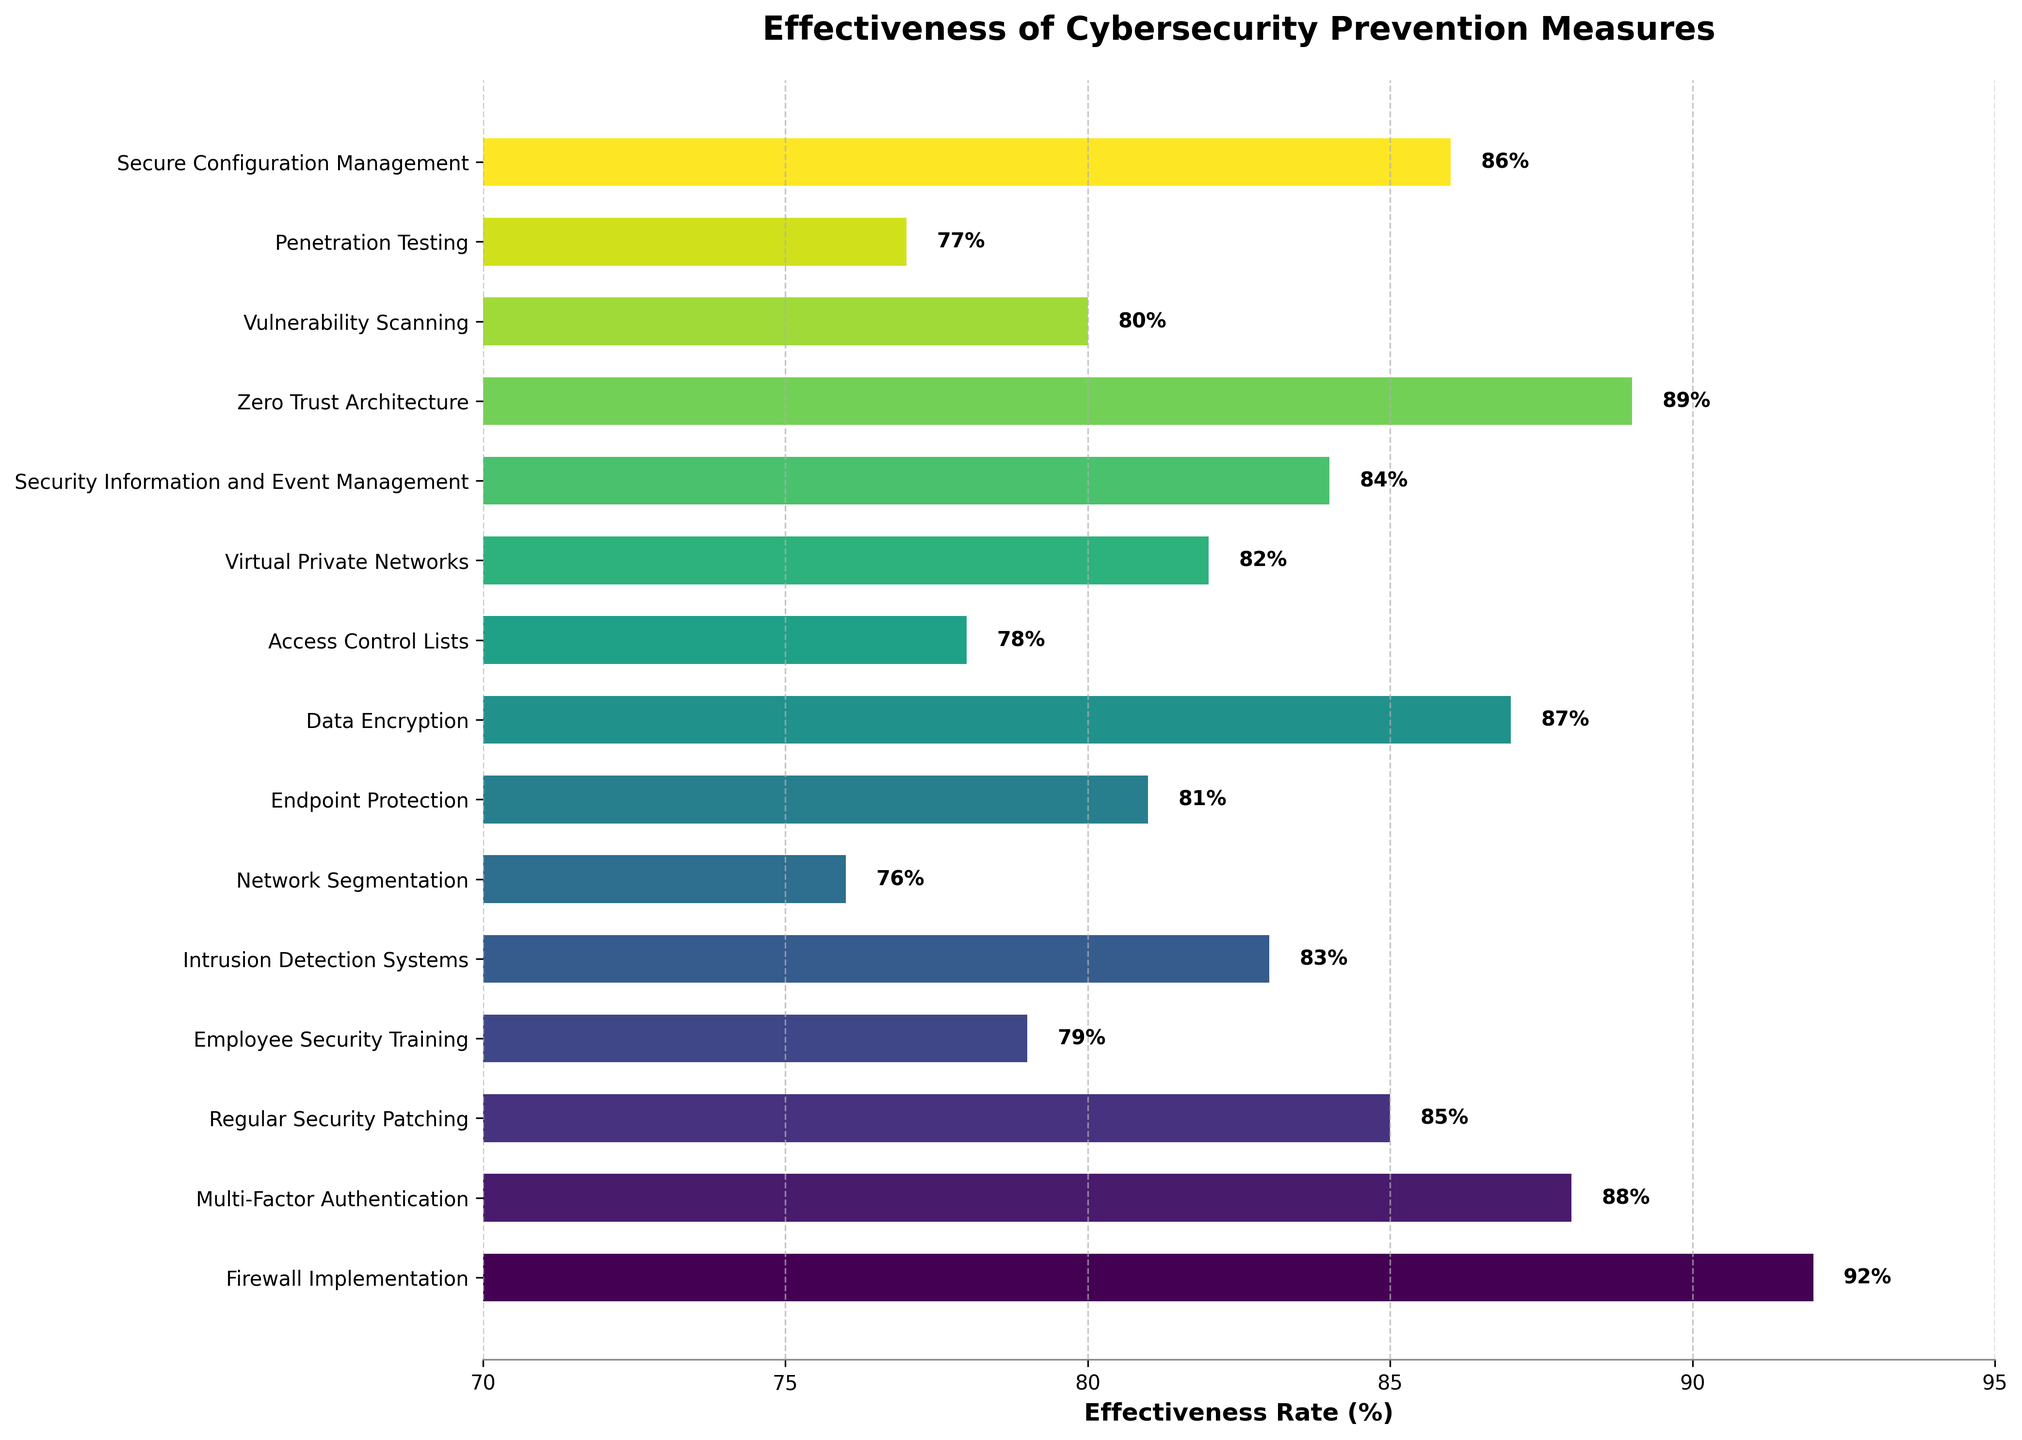Which cybersecurity measure is most effective according to the figure? The measure with the highest effectiveness rate is the most effective. In the figure, Firewall Implementation has the highest effectiveness rate at 92%.
Answer: Firewall Implementation How does the effectiveness of Multi-Factor Authentication compare to that of Data Encryption? To compare the effectiveness, we need to look at the effectiveness rates for both measures. Multi-Factor Authentication has an 88% effectiveness rate and Data Encryption has an 87% effectiveness rate.
Answer: Multi-Factor Authentication is slightly more effective Which measure has the lowest effectiveness rate? The measure with the smallest bar or lowest number in the effectiveness rate is the least effective. In the figure, Network Segmentation has the lowest effectiveness rate at 76%.
Answer: Network Segmentation By how much does the effectiveness of Zero Trust Architecture exceed Access Control Lists? To find the difference in effectiveness, we subtract the smaller rate from the higher rate. The effectiveness rate of Zero Trust Architecture is 89% and that of Access Control Lists is 78%. So, 89% - 78% = 11%.
Answer: 11% What is the average effectiveness rate of the top three most effective measures? To get the average, sum the effectiveness rates of the top three measures and divide by three. The top three measures are Firewall Implementation (92%), Zero Trust Architecture (89%), and Multi-Factor Authentication (88%). So, (92% + 89% + 88%) / 3 = 89.67%.
Answer: 89.67% Which measure among Endpoint Protection, Intrusion Detection Systems, and Penetration Testing has the highest effectiveness rate? We look at the effectiveness rates of Endpoint Protection (81%), Intrusion Detection Systems (83%), and Penetration Testing (77%). Intrusion Detection Systems has the highest rate.
Answer: Intrusion Detection Systems What are the two closest measures in terms of effectiveness rate? To find the closest measures, compare the differences between the adjacent bars. Data Encryption and Secure Configuration Management are closest with rates of 87% and 86%, respectively.
Answer: Data Encryption and Secure Configuration Management Which measure is directly above Multi-Factor Authentication in terms of effectiveness rate? Multi-Factor Authentication has an effectiveness rate of 88%. The measure directly above is Zero Trust Architecture with an effectiveness rate of 89%.
Answer: Zero Trust Architecture What is the total combined effectiveness rate of Firewall Implementation, Regular Security Patching, and Employee Security Training? To find the total combined rate, add the effectiveness rates of these measures. Firewall Implementation (92%), Regular Security Patching (85%), and Employee Security Training (79%) sum up to 92% + 85% + 79% = 256%.
Answer: 256% Between Firewall Implementation and Regular Security Patching, which measure’s effectiveness rate is displayed closer to the maximum limit of the x-axis? Firewall Implementation has an effectiveness rate of 92%, and Regular Security Patching has a rate of 85%. The x-axis maximum is set at 95%, so Firewall Implementation is closer to 95%.
Answer: Firewall Implementation 